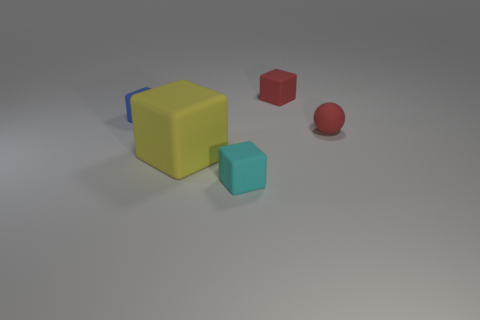Subtract 1 blocks. How many blocks are left? 3 Add 3 big cubes. How many objects exist? 8 Subtract all cubes. How many objects are left? 1 Add 4 small red objects. How many small red objects are left? 6 Add 1 small red blocks. How many small red blocks exist? 2 Subtract 0 blue cylinders. How many objects are left? 5 Subtract all cyan cubes. Subtract all cyan matte objects. How many objects are left? 3 